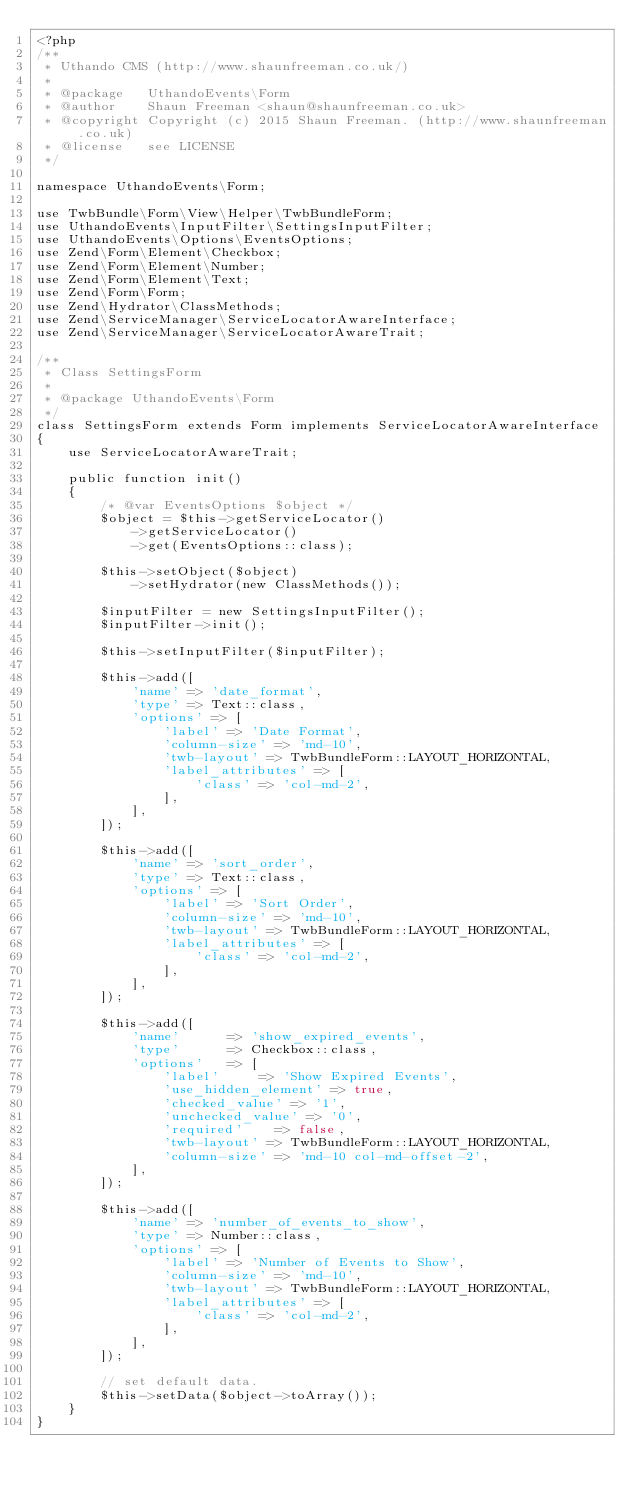<code> <loc_0><loc_0><loc_500><loc_500><_PHP_><?php
/**
 * Uthando CMS (http://www.shaunfreeman.co.uk/)
 *
 * @package   UthandoEvents\Form
 * @author    Shaun Freeman <shaun@shaunfreeman.co.uk>
 * @copyright Copyright (c) 2015 Shaun Freeman. (http://www.shaunfreeman.co.uk)
 * @license   see LICENSE
 */

namespace UthandoEvents\Form;

use TwbBundle\Form\View\Helper\TwbBundleForm;
use UthandoEvents\InputFilter\SettingsInputFilter;
use UthandoEvents\Options\EventsOptions;
use Zend\Form\Element\Checkbox;
use Zend\Form\Element\Number;
use Zend\Form\Element\Text;
use Zend\Form\Form;
use Zend\Hydrator\ClassMethods;
use Zend\ServiceManager\ServiceLocatorAwareInterface;
use Zend\ServiceManager\ServiceLocatorAwareTrait;

/**
 * Class SettingsForm
 *
 * @package UthandoEvents\Form
 */
class SettingsForm extends Form implements ServiceLocatorAwareInterface
{
    use ServiceLocatorAwareTrait;

    public function init()
    {
        /* @var EventsOptions $object */
        $object = $this->getServiceLocator()
            ->getServiceLocator()
            ->get(EventsOptions::class);

        $this->setObject($object)
            ->setHydrator(new ClassMethods());

        $inputFilter = new SettingsInputFilter();
        $inputFilter->init();

        $this->setInputFilter($inputFilter);

        $this->add([
            'name' => 'date_format',
            'type' => Text::class,
            'options' => [
                'label' => 'Date Format',
                'column-size' => 'md-10',
                'twb-layout' => TwbBundleForm::LAYOUT_HORIZONTAL,
                'label_attributes' => [
                    'class' => 'col-md-2',
                ],
            ],
        ]);

        $this->add([
            'name' => 'sort_order',
            'type' => Text::class,
            'options' => [
                'label' => 'Sort Order',
                'column-size' => 'md-10',
                'twb-layout' => TwbBundleForm::LAYOUT_HORIZONTAL,
                'label_attributes' => [
                    'class' => 'col-md-2',
                ],
            ],
        ]);

        $this->add([
            'name'			=> 'show_expired_events',
            'type'			=> Checkbox::class,
            'options'		=> [
                'label'			=> 'Show Expired Events',
                'use_hidden_element' => true,
                'checked_value' => '1',
                'unchecked_value' => '0',
                'required' 		=> false,
                'twb-layout' => TwbBundleForm::LAYOUT_HORIZONTAL,
                'column-size' => 'md-10 col-md-offset-2',
            ],
        ]);

        $this->add([
            'name' => 'number_of_events_to_show',
            'type' => Number::class,
            'options' => [
                'label' => 'Number of Events to Show',
                'column-size' => 'md-10',
                'twb-layout' => TwbBundleForm::LAYOUT_HORIZONTAL,
                'label_attributes' => [
                    'class' => 'col-md-2',
                ],
            ],
        ]);

        // set default data.
        $this->setData($object->toArray());
    }
}
</code> 